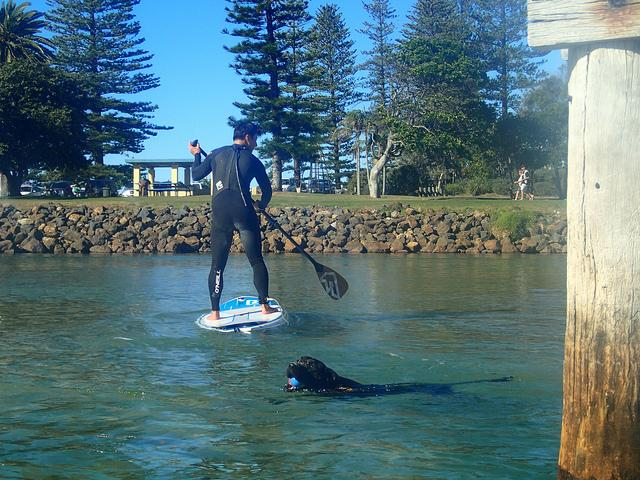What will the dog do with the ball? Please explain your reasoning. give human. The dog wants to return the ball. 